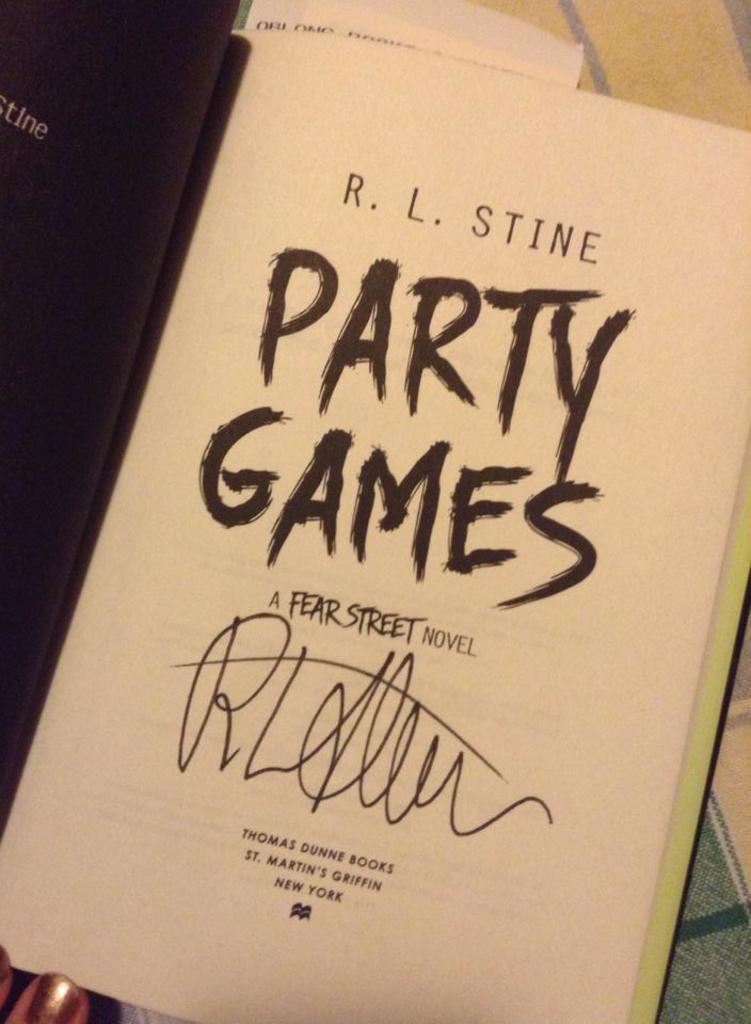<image>
Write a terse but informative summary of the picture. The signature of RL Stine on the opening page of the book Party Games. 